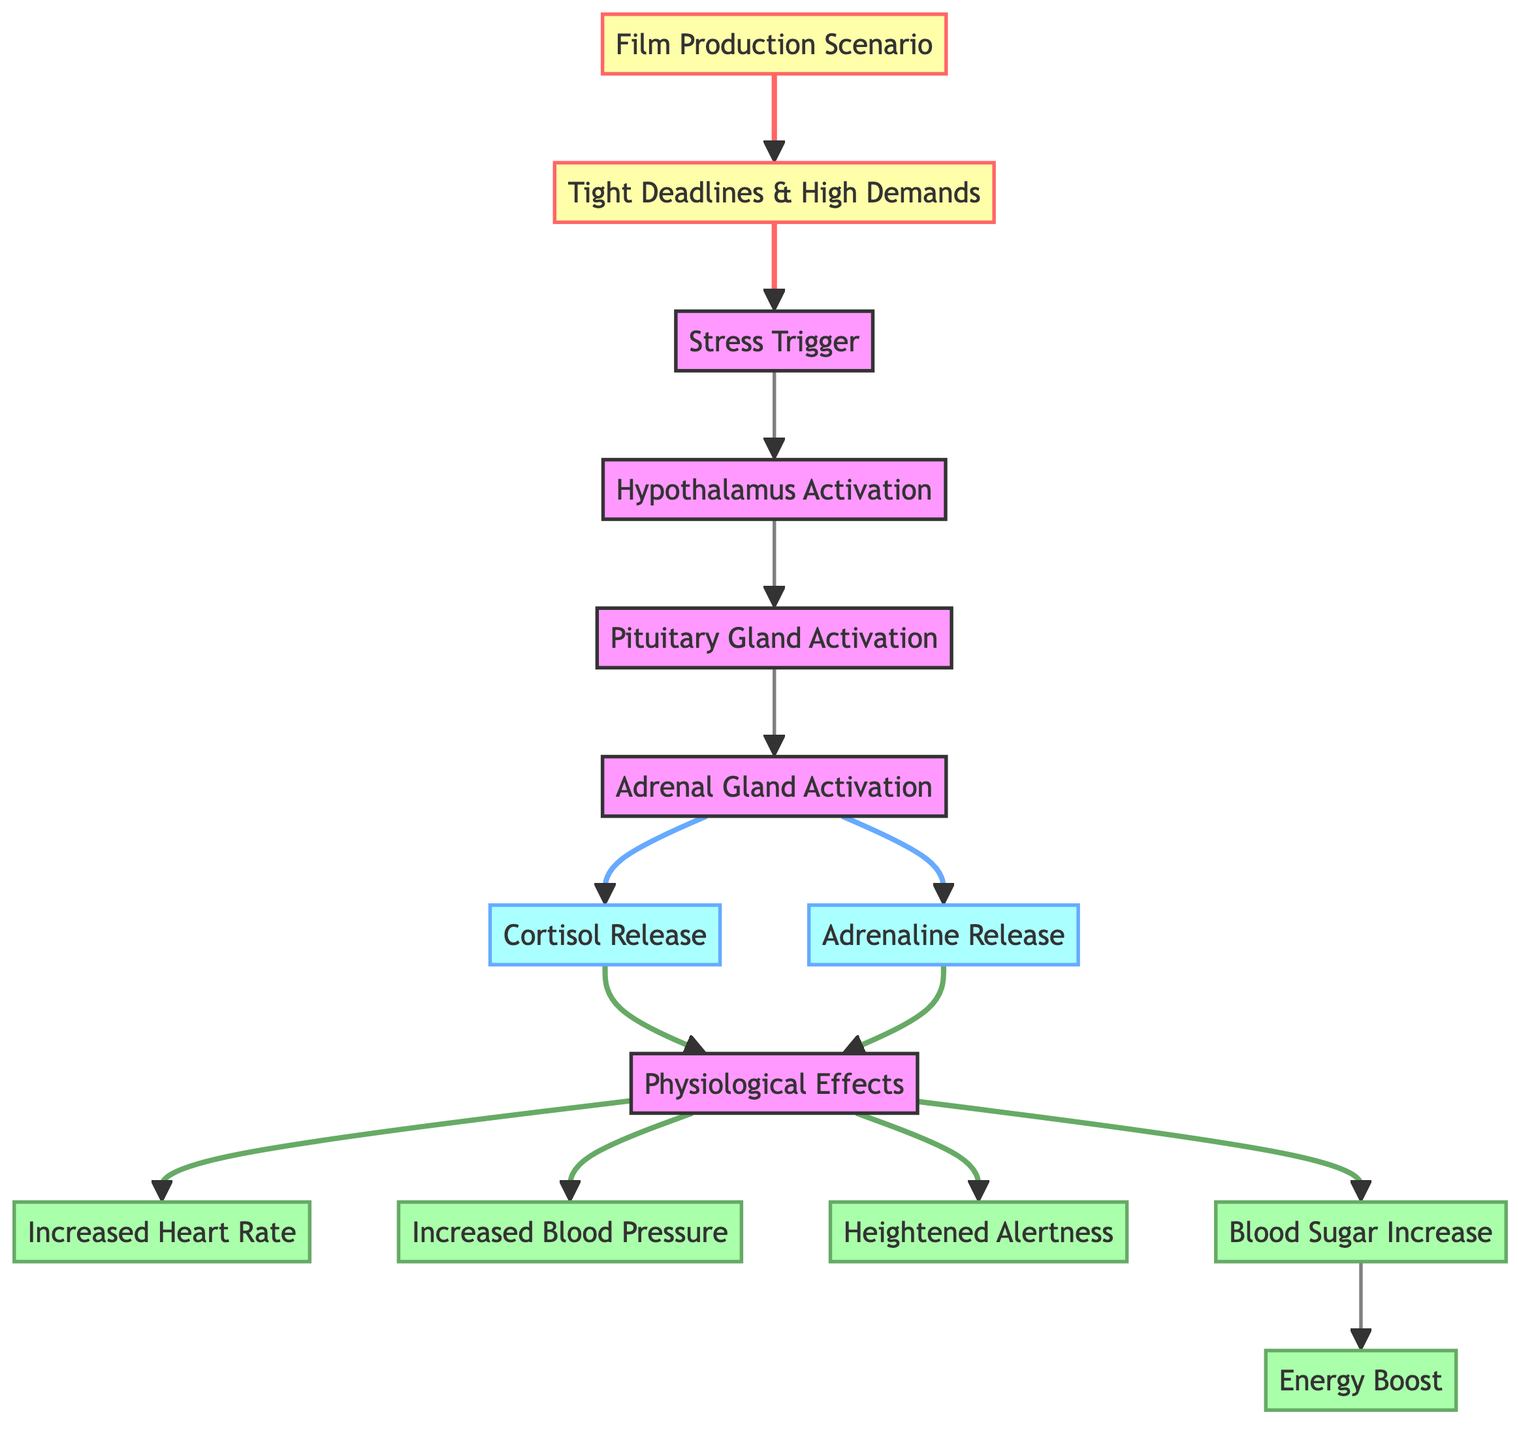What is the initial stress trigger in the diagram? The diagram indicates that the initial stress trigger is "Stress Trigger," which leads to the subsequent chain of activations.
Answer: Stress Trigger How many physiological effects are listed in the diagram? There are five physiological effects listed in the diagram, which are increased heart rate, increased blood pressure, heightened alertness, blood sugar increase, and energy boost.
Answer: 5 Which gland is activated after the hypothalamus? The sequence in the diagram shows that after the hypothalamus is activated, the next gland activated is the "Pituitary Gland."
Answer: Pituitary Gland What hormones are released during the stress response? The diagram specifically outlines the hormones that are released during the stress response as cortisol and adrenaline.
Answer: Cortisol and Adrenaline What effect is associated with an increase in blood sugar? According to the diagram, the effect associated with an increase in blood sugar is specifically "Energy Boost."
Answer: Energy Boost What is the last physiological effect in the diagram? The last physiological effect presented in the flow is "Energy Boost," which follows the increase in blood sugar.
Answer: Energy Boost Which part of the stress response timeline involves the adrenal gland? The portion of the timeline in the diagram that involves the adrenal gland is directly after the pituitary gland activation and before the release of cortisol and adrenaline.
Answer: Adrenal Gland Activation How many nodes represent hormonal releases in the diagram? The diagram contains two nodes that represent hormonal releases: cortisol release and adrenaline release.
Answer: 2 